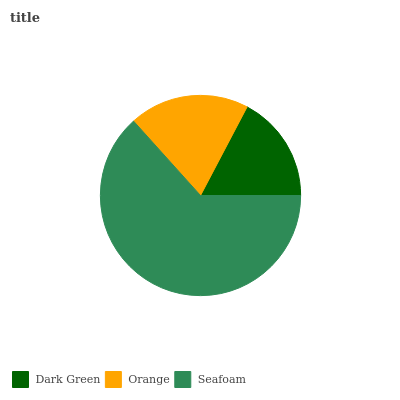Is Dark Green the minimum?
Answer yes or no. Yes. Is Seafoam the maximum?
Answer yes or no. Yes. Is Orange the minimum?
Answer yes or no. No. Is Orange the maximum?
Answer yes or no. No. Is Orange greater than Dark Green?
Answer yes or no. Yes. Is Dark Green less than Orange?
Answer yes or no. Yes. Is Dark Green greater than Orange?
Answer yes or no. No. Is Orange less than Dark Green?
Answer yes or no. No. Is Orange the high median?
Answer yes or no. Yes. Is Orange the low median?
Answer yes or no. Yes. Is Seafoam the high median?
Answer yes or no. No. Is Seafoam the low median?
Answer yes or no. No. 